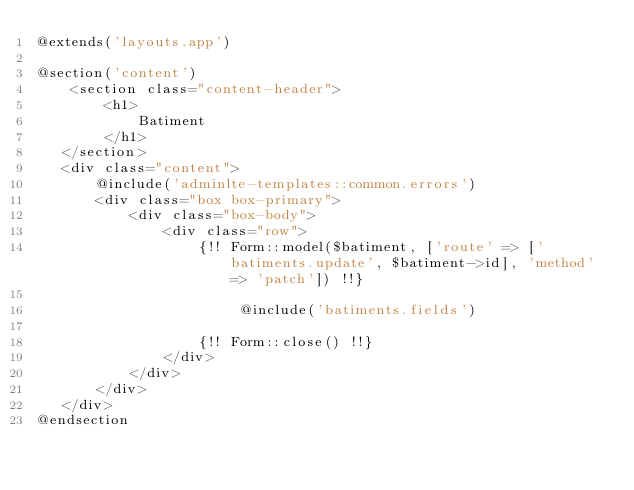Convert code to text. <code><loc_0><loc_0><loc_500><loc_500><_PHP_>@extends('layouts.app')

@section('content')
    <section class="content-header">
        <h1>
            Batiment
        </h1>
   </section>
   <div class="content">
       @include('adminlte-templates::common.errors')
       <div class="box box-primary">
           <div class="box-body">
               <div class="row">
                   {!! Form::model($batiment, ['route' => ['batiments.update', $batiment->id], 'method' => 'patch']) !!}

                        @include('batiments.fields')

                   {!! Form::close() !!}
               </div>
           </div>
       </div>
   </div>
@endsection</code> 